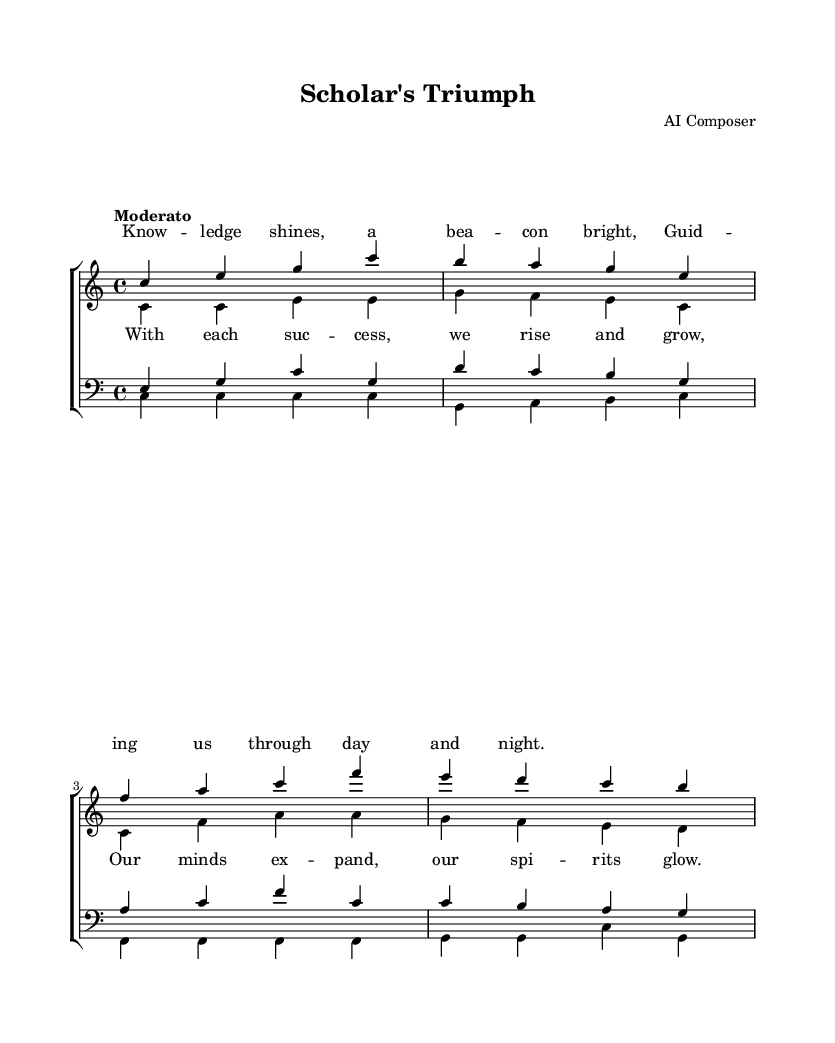What is the key signature of this music? The key signature is C major, which has no sharps or flats.
Answer: C major What is the time signature of the piece? The time signature is indicated at the beginning of the score as 4/4, meaning there are four beats in a measure.
Answer: 4/4 What is the tempo marking given for this music? The tempo marking is “Moderato,” which indicates a moderate speed for the performance.
Answer: Moderato Which choir parts are included in the arrangement? The arrangement includes Soprano, Alto, Tenor, and Bass parts, indicated by separate staff groups in the score.
Answer: Soprano, Alto, Tenor, Bass What is the lyrical theme of the chorus? The chorus promotes the idea of growth and achievement through success, emphasizing the expansion of minds and uplifting spirits.
Answer: Growth and achievement How many measures are in the soprano music section? The soprano part consists of four measures, as indicated by the music notation in that staff.
Answer: Four measures What mood does the harmony primarily evoke in this choral arrangement? The harmony in this arrangement evokes an uplifting and celebratory mood, suitable for celebrating academic achievements.
Answer: Uplifting 